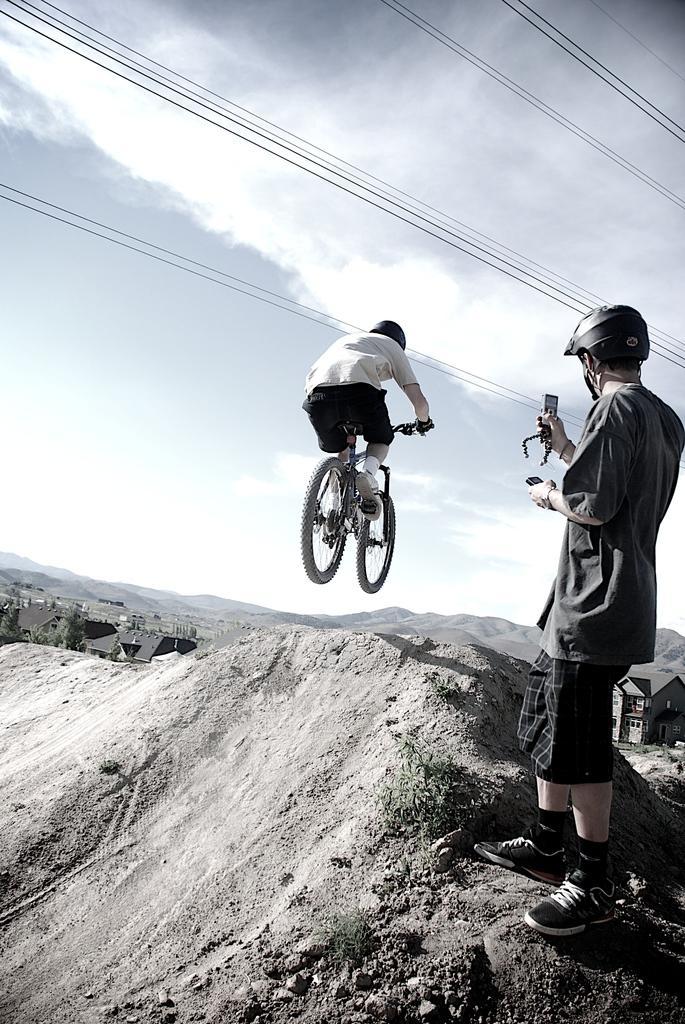Please provide a concise description of this image. In this image I can see a person standing and another person is riding the bicycle in the air. And I can also see the sky. 